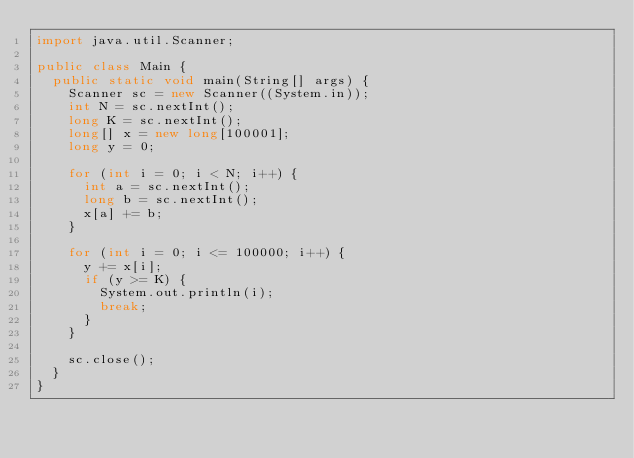Convert code to text. <code><loc_0><loc_0><loc_500><loc_500><_Java_>import java.util.Scanner;

public class Main {
	public static void main(String[] args) {
		Scanner sc = new Scanner((System.in));
		int N = sc.nextInt();
		long K = sc.nextInt();
		long[] x = new long[100001];
		long y = 0;
		
		for (int i = 0; i < N; i++) {
			int a = sc.nextInt();
			long b = sc.nextInt();
			x[a] += b;
		}
		
		for (int i = 0; i <= 100000; i++) {
			y += x[i];
			if (y >= K) {
				System.out.println(i);
				break;
			}
		}

		sc.close();
	}
}
</code> 